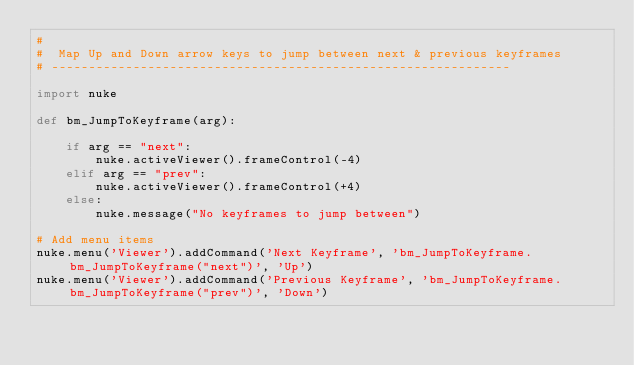<code> <loc_0><loc_0><loc_500><loc_500><_Python_>#
#  Map Up and Down arrow keys to jump between next & previous keyframes
# --------------------------------------------------------------

import nuke

def bm_JumpToKeyframe(arg):

    if arg == "next":
        nuke.activeViewer().frameControl(-4)
    elif arg == "prev":
        nuke.activeViewer().frameControl(+4)
    else:
        nuke.message("No keyframes to jump between")

# Add menu items
nuke.menu('Viewer').addCommand('Next Keyframe', 'bm_JumpToKeyframe.bm_JumpToKeyframe("next")', 'Up')
nuke.menu('Viewer').addCommand('Previous Keyframe', 'bm_JumpToKeyframe.bm_JumpToKeyframe("prev")', 'Down')
</code> 